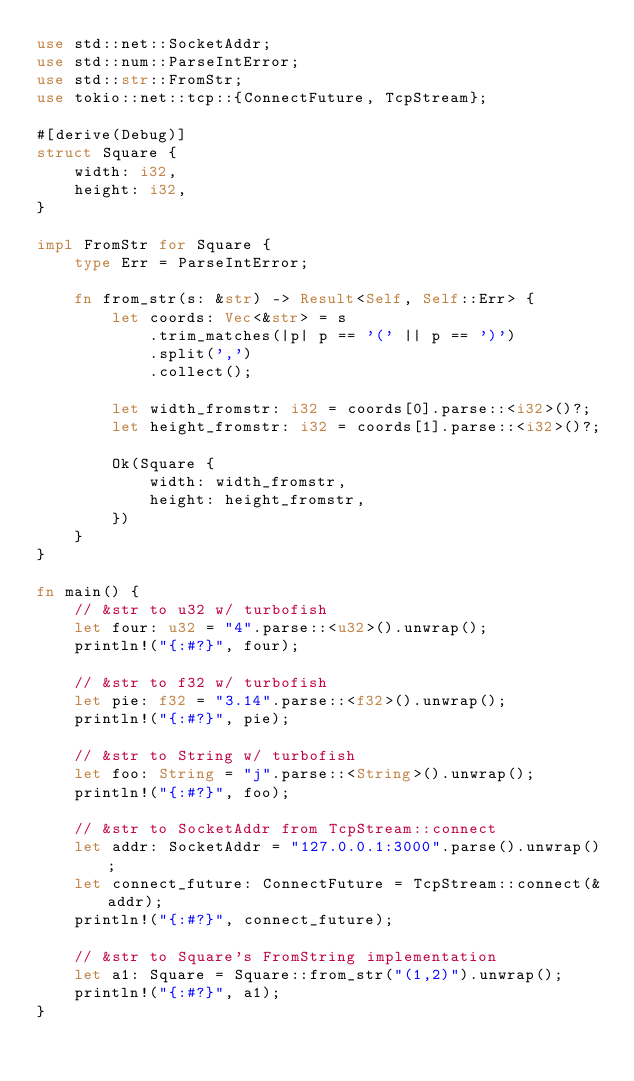Convert code to text. <code><loc_0><loc_0><loc_500><loc_500><_Rust_>use std::net::SocketAddr;
use std::num::ParseIntError;
use std::str::FromStr;
use tokio::net::tcp::{ConnectFuture, TcpStream};

#[derive(Debug)]
struct Square {
    width: i32,
    height: i32,
}

impl FromStr for Square {
    type Err = ParseIntError;

    fn from_str(s: &str) -> Result<Self, Self::Err> {
        let coords: Vec<&str> = s
            .trim_matches(|p| p == '(' || p == ')')
            .split(',')
            .collect();

        let width_fromstr: i32 = coords[0].parse::<i32>()?;
        let height_fromstr: i32 = coords[1].parse::<i32>()?;

        Ok(Square {
            width: width_fromstr,
            height: height_fromstr,
        })
    }
}

fn main() {
    // &str to u32 w/ turbofish
    let four: u32 = "4".parse::<u32>().unwrap();
    println!("{:#?}", four);

    // &str to f32 w/ turbofish
    let pie: f32 = "3.14".parse::<f32>().unwrap();
    println!("{:#?}", pie);

    // &str to String w/ turbofish
    let foo: String = "j".parse::<String>().unwrap();
    println!("{:#?}", foo);

    // &str to SocketAddr from TcpStream::connect
    let addr: SocketAddr = "127.0.0.1:3000".parse().unwrap();
    let connect_future: ConnectFuture = TcpStream::connect(&addr);
    println!("{:#?}", connect_future);

    // &str to Square's FromString implementation
    let a1: Square = Square::from_str("(1,2)").unwrap();
    println!("{:#?}", a1);
}
</code> 